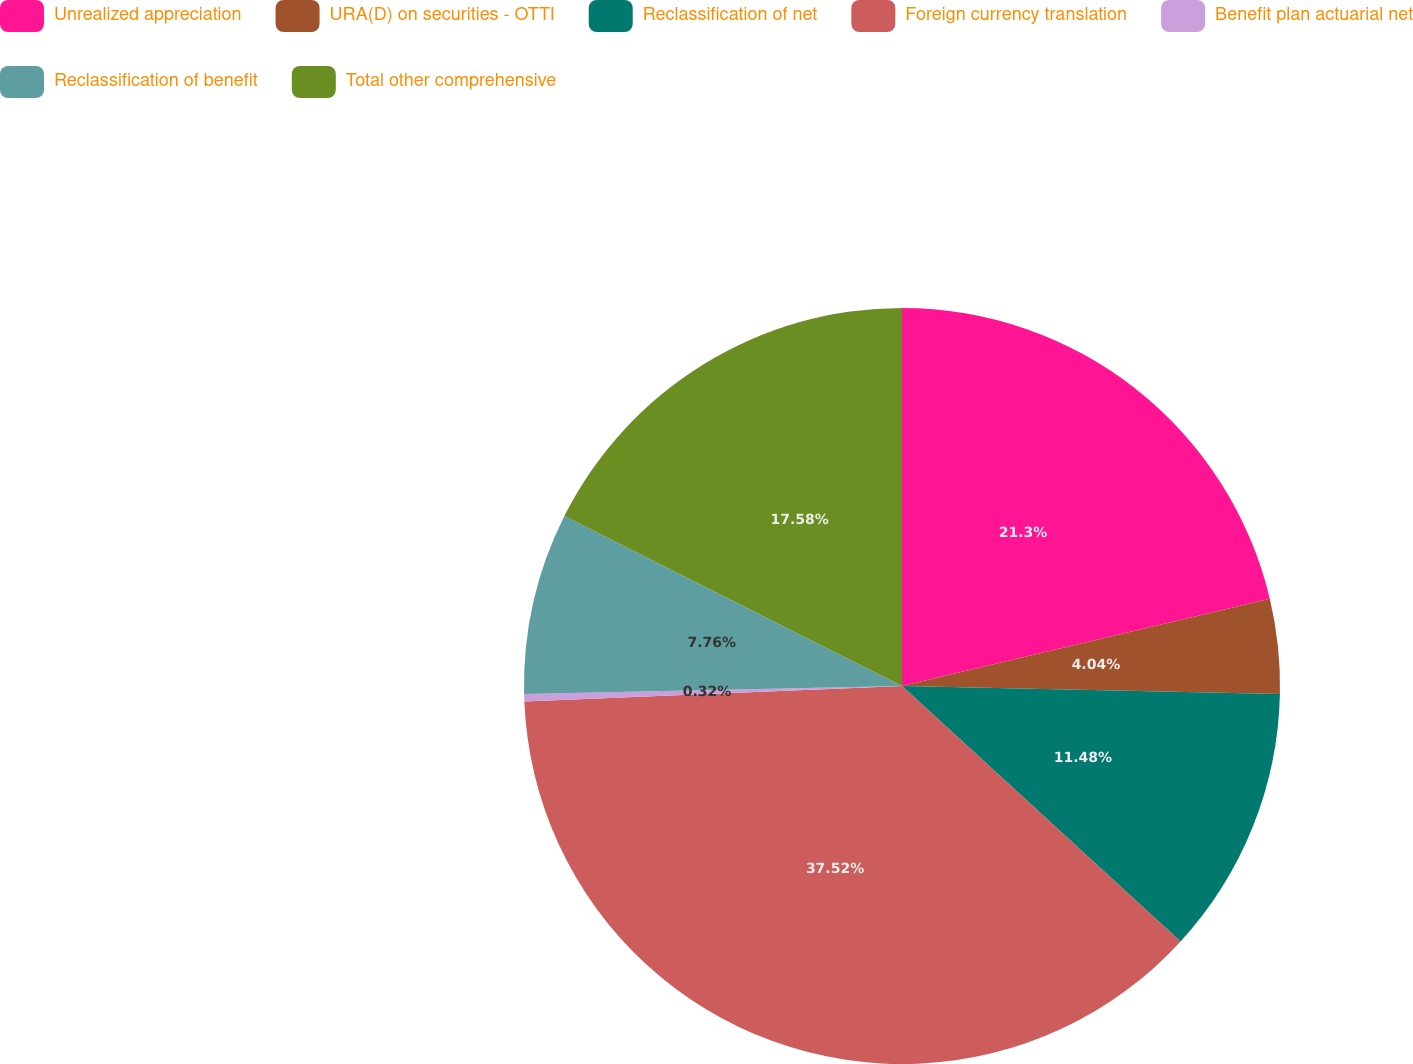Convert chart. <chart><loc_0><loc_0><loc_500><loc_500><pie_chart><fcel>Unrealized appreciation<fcel>URA(D) on securities - OTTI<fcel>Reclassification of net<fcel>Foreign currency translation<fcel>Benefit plan actuarial net<fcel>Reclassification of benefit<fcel>Total other comprehensive<nl><fcel>21.3%<fcel>4.04%<fcel>11.48%<fcel>37.53%<fcel>0.32%<fcel>7.76%<fcel>17.58%<nl></chart> 